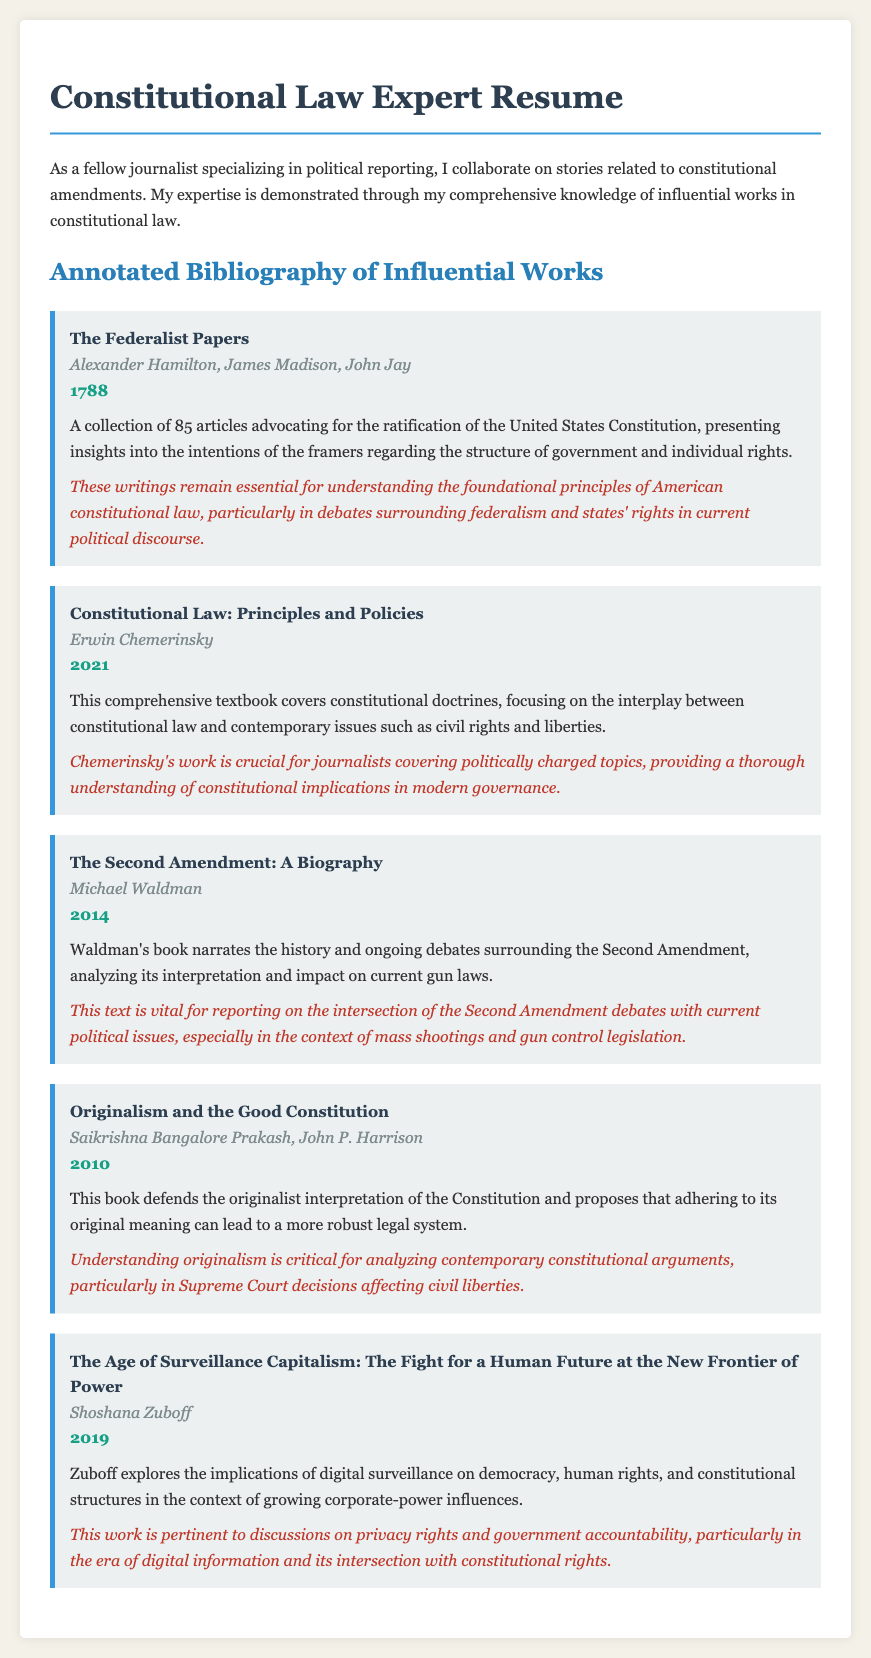What is the title of the first entry in the bibliography? The first entry details "The Federalist Papers," which is listed among the influential works.
Answer: The Federalist Papers Who are the authors of "Constitutional Law: Principles and Policies"? The authors of this work are Erwin Chemerinsky, showing his contribution to understanding constitutional doctrines.
Answer: Erwin Chemerinsky In what year was "The Second Amendment: A Biography" published? The publication year for this book is provided, indicating when the discussions around the Second Amendment began to gain traction.
Answer: 2014 What is the primary subject of Shoshana Zuboff's book? The book discusses digital surveillance and its implications on democracy and human rights, highlighting contemporary concerns in governance.
Answer: Digital surveillance Which constitutional interpretation is defended in "Originalism and the Good Constitution"? The focus of this book lies in promoting the originalist interpretation, which is key to understanding contemporary constitutional debates.
Answer: Originalism How many articles make up "The Federalist Papers"? The document specifies the number of articles that collectively advocate for the ratification of the U.S. Constitution and frame the original intentions.
Answer: 85 What significant contemporary issue is linked to "The Second Amendment: A Biography"? The book connects deeply with current debates surrounding gun laws, a pressing political topic encountered in reporting.
Answer: Gun control What is the main focus of Erwin Chemerinsky's textbook? The work emphasizes constitutional doctrines along with their relevance to current civil rights and liberties issues in the political landscape.
Answer: Civil rights and liberties What publication year is given for the "Age of Surveillance Capitalism"? The document provides a specific year when this pivotal work on digital influence was published.
Answer: 2019 